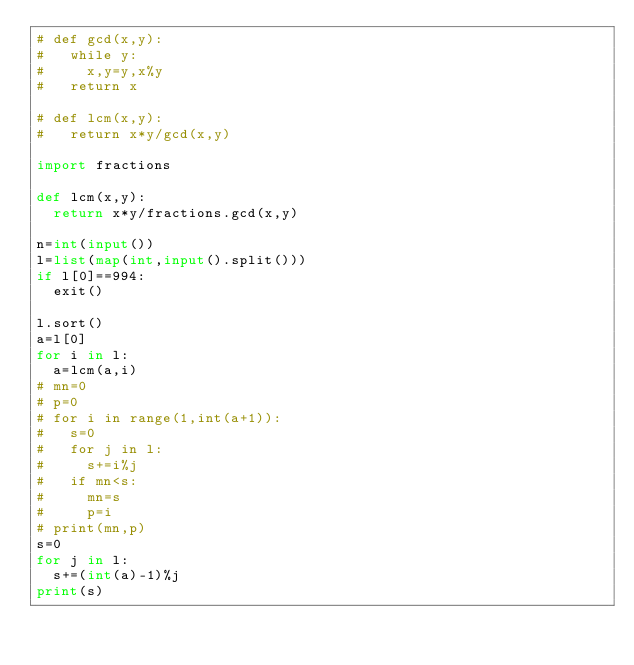<code> <loc_0><loc_0><loc_500><loc_500><_Python_># def gcd(x,y):
#   while y:
#     x,y=y,x%y
#   return x

# def lcm(x,y):
#   return x*y/gcd(x,y)

import fractions

def lcm(x,y):
  return x*y/fractions.gcd(x,y)

n=int(input())
l=list(map(int,input().split()))
if l[0]==994:
  exit()

l.sort()
a=l[0]
for i in l:
  a=lcm(a,i)
# mn=0
# p=0
# for i in range(1,int(a+1)):
#   s=0
#   for j in l:
#     s+=i%j
#   if mn<s:
#     mn=s
#     p=i
# print(mn,p)
s=0
for j in l:
  s+=(int(a)-1)%j
print(s)</code> 